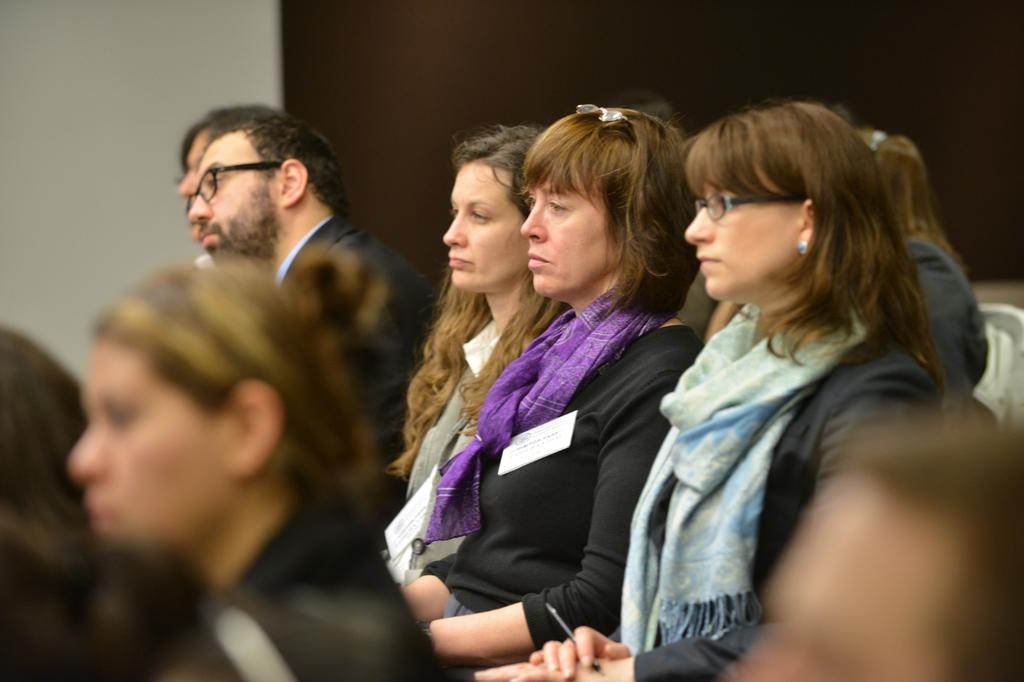What is the visual effect on the foreground of the picture? The foreground of the picture is blurred. What can be seen in the center of the picture? There are women sitting in chairs in the center of the picture. Can you describe the person in the background of the picture? There is a person in a suit in the background of the picture. What type of pipe is the frog using to play a meal in the image? There is no frog or pipe present in the image, and no meal is being played. 